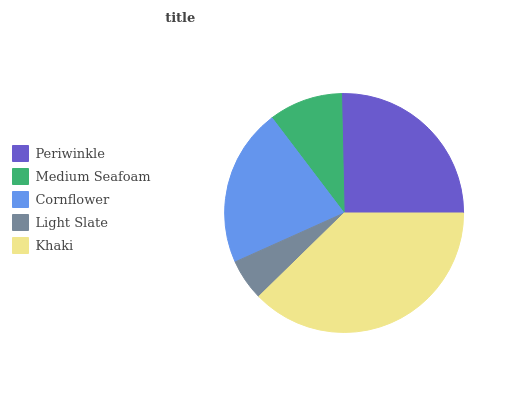Is Light Slate the minimum?
Answer yes or no. Yes. Is Khaki the maximum?
Answer yes or no. Yes. Is Medium Seafoam the minimum?
Answer yes or no. No. Is Medium Seafoam the maximum?
Answer yes or no. No. Is Periwinkle greater than Medium Seafoam?
Answer yes or no. Yes. Is Medium Seafoam less than Periwinkle?
Answer yes or no. Yes. Is Medium Seafoam greater than Periwinkle?
Answer yes or no. No. Is Periwinkle less than Medium Seafoam?
Answer yes or no. No. Is Cornflower the high median?
Answer yes or no. Yes. Is Cornflower the low median?
Answer yes or no. Yes. Is Periwinkle the high median?
Answer yes or no. No. Is Light Slate the low median?
Answer yes or no. No. 